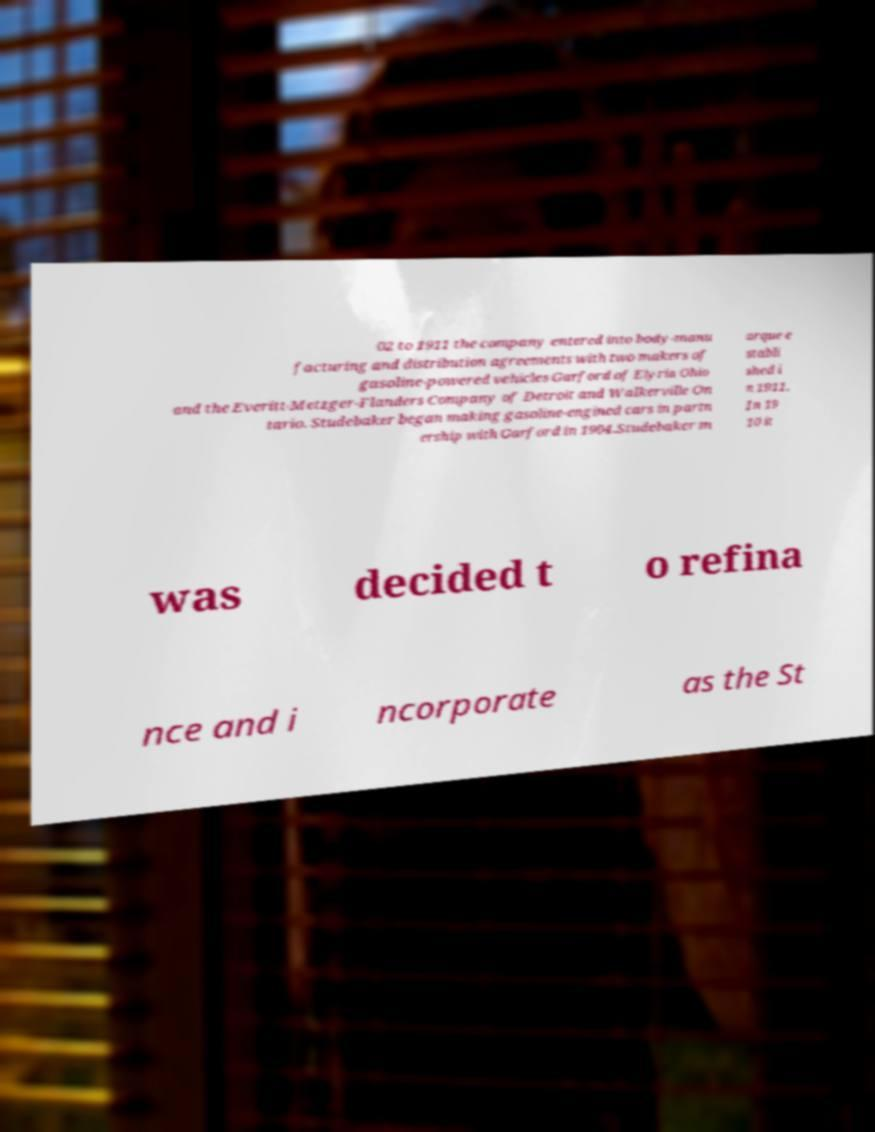What messages or text are displayed in this image? I need them in a readable, typed format. 02 to 1911 the company entered into body-manu facturing and distribution agreements with two makers of gasoline-powered vehicles Garford of Elyria Ohio and the Everitt-Metzger-Flanders Company of Detroit and Walkerville On tario. Studebaker began making gasoline-engined cars in partn ership with Garford in 1904.Studebaker m arque e stabli shed i n 1911. In 19 10 it was decided t o refina nce and i ncorporate as the St 